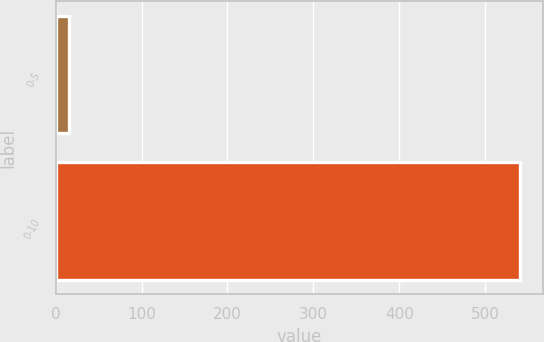<chart> <loc_0><loc_0><loc_500><loc_500><bar_chart><fcel>0-5<fcel>0-10<nl><fcel>15<fcel>540<nl></chart> 